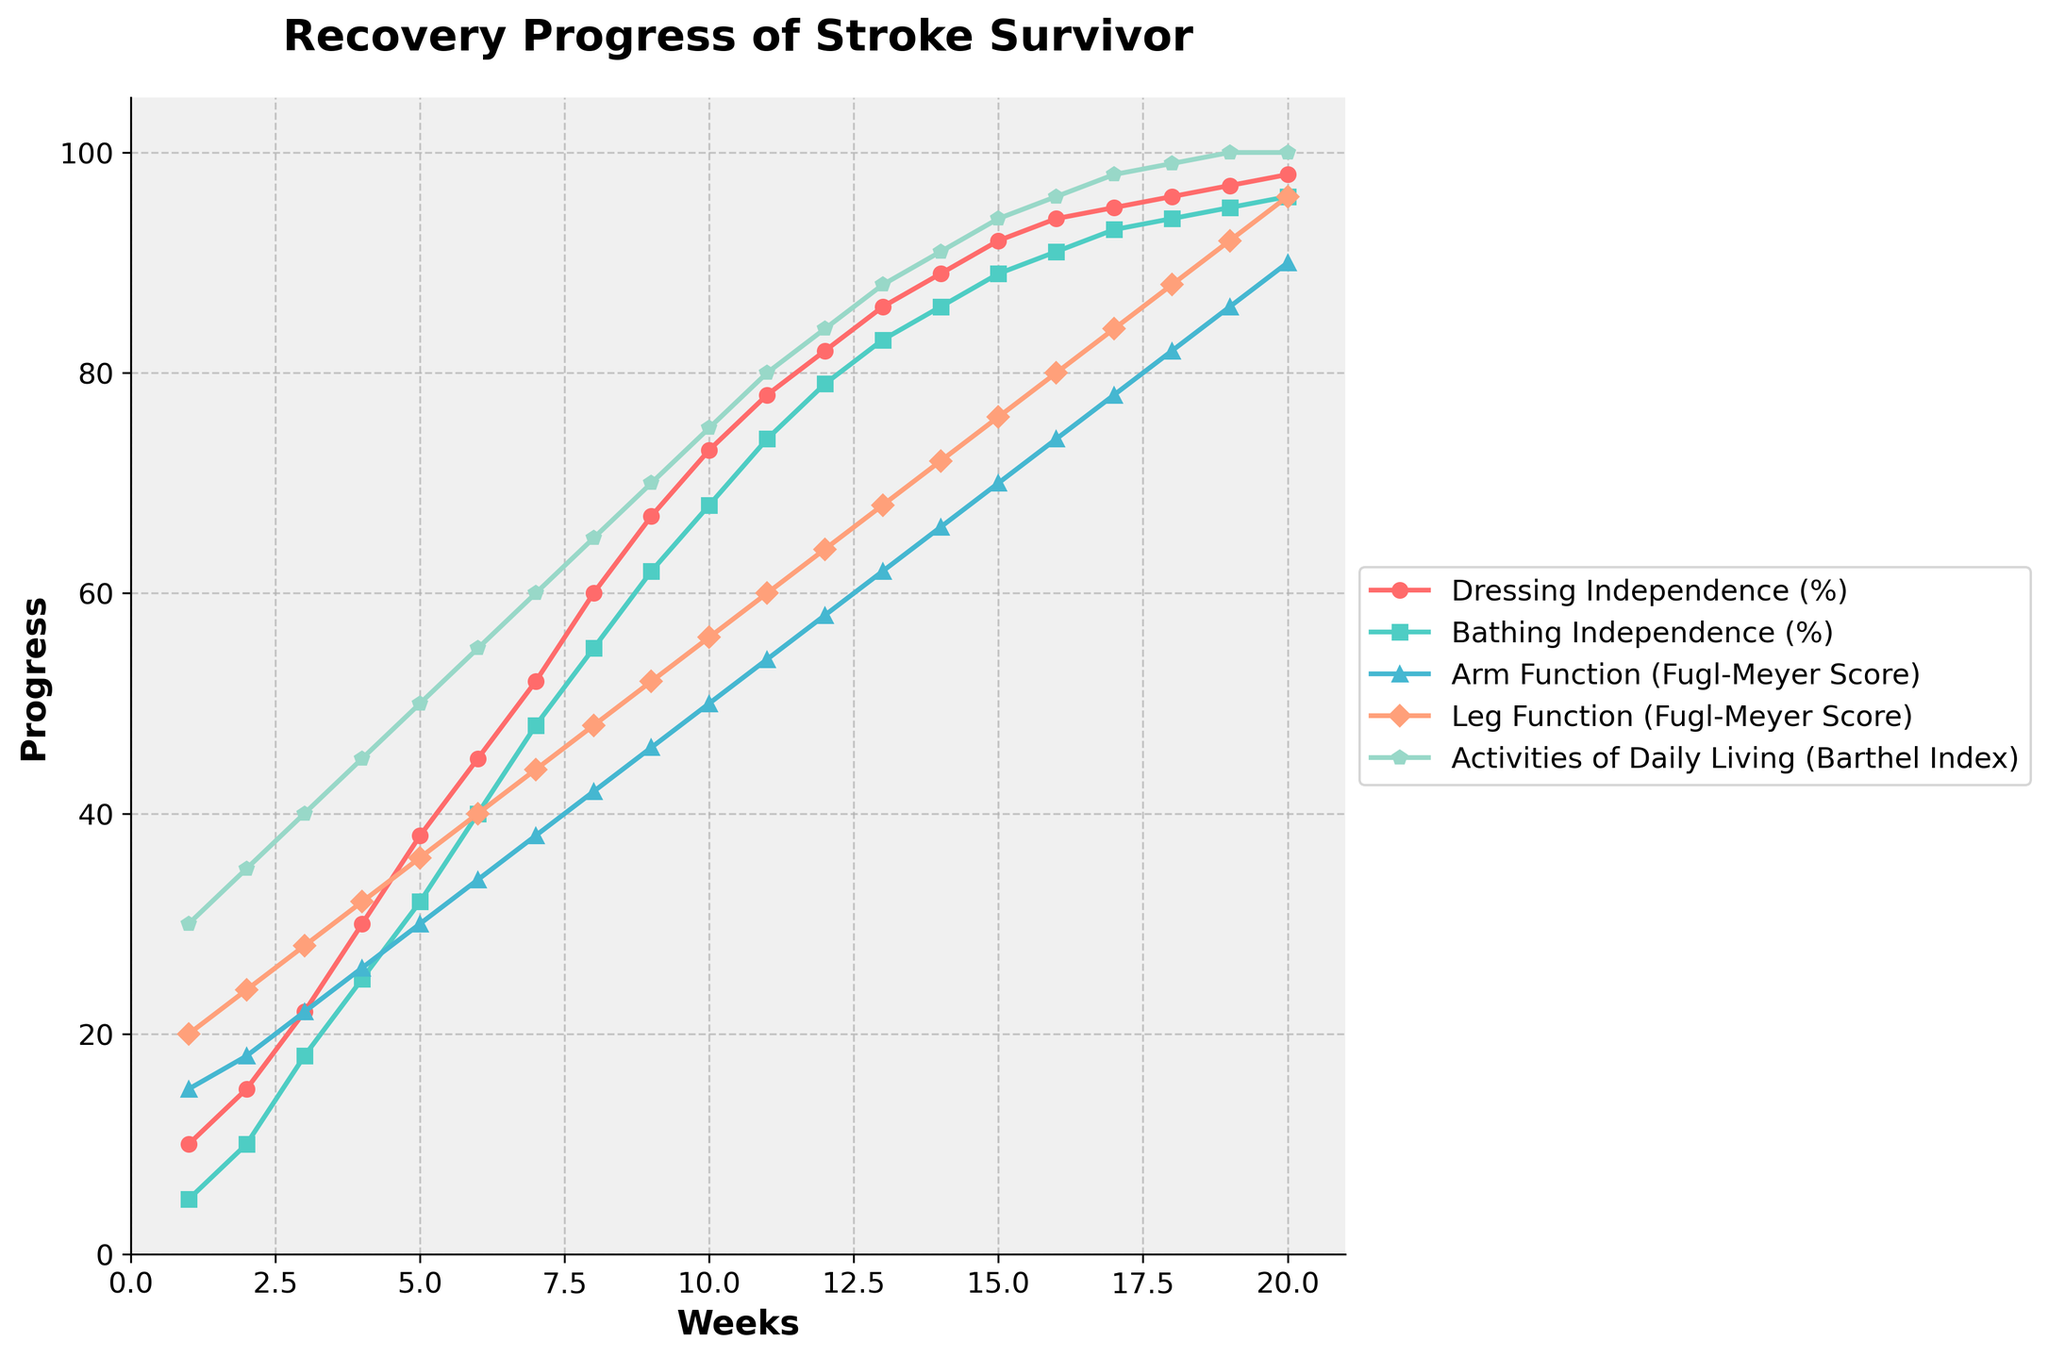What percentage of dressing independence is achieved by the 8th week? Look at the data point for week 8 under 'Dressing Independence (%). The value is 60%.
Answer: 60% Which improves faster initially, arm function or leg function? Compare the slope of the lines representing 'Arm Function (Fugl-Meyer Score)' and 'Leg Function (Fugl-Meyer Score)' in the early weeks. The leg function shows a steeper increase initially.
Answer: Leg function By how much does the Bathing Independence (%) increase from week 3 to week 6? Subtract the value of week 3 from the value of week 6 for 'Bathing Independence (%)'. The increase is from 18% to 40%. So, 40 - 18 = 22.
Answer: 22% What is the Barthel Index value at the midpoint (week 10) of the study? Find the Barthel Index value corresponding to week 10, which is 75.
Answer: 75 Are there any weeks where Arm Function and Leg Function are equal, and if so, which ones? Check the values for 'Arm Function (Fugl-Meyer Score)' and 'Leg Function (Fugl-Meyer Score)' at each week. They are equal at week 20, both at a score of 90.
Answer: Week 20 On which week do both Dressing Independence (%) and Bathing Independence (%) scores exceed 90%? Identify the week where both 'Dressing Independence (%)' and 'Bathing Independence (%)' are above 90%. This occurs at week 20.
Answer: Week 20 What is the average Barthel Index score over the first 5 weeks? Add the Barthel Index scores for weeks 1 to 5 and divide by 5. (30 + 35 + 40 + 45 + 50) / 5 = 40.
Answer: 40 Between weeks 9 and 12, which function shows the greatest absolute improvement? Calculate the difference for each function between weeks 9 and 12 and compare. Arm Function: 58 - 46 = 12; Leg Function: 64 - 52 = 12; Dressing Independence: 82 - 67 = 15; Bathing Independence: 79 - 62 = 17; Barthel Index: 84 - 70 = 14. Bathing Independence shows the greatest improvement.
Answer: Bathing Independence Compare the rate of increase in Arm Function (Fugl-Meyer Score) and Dressing Independence (%) between weeks 5 and 10. Calculate the rate for each by comparing the change. Dressing Independence: (73 - 38) / 5 = 7% per week, Arm Function: (50 - 30) / 5 = 4 points per week. Dressing Independence has a higher rate of increase.
Answer: Dressing Independence Which indicator has the highest final value, and what is it? Refer to the data at week 20, and find the maximum value among the indicators. 'Dressing Independence (%)' at 98%.
Answer: Dressing Independence, 98% 